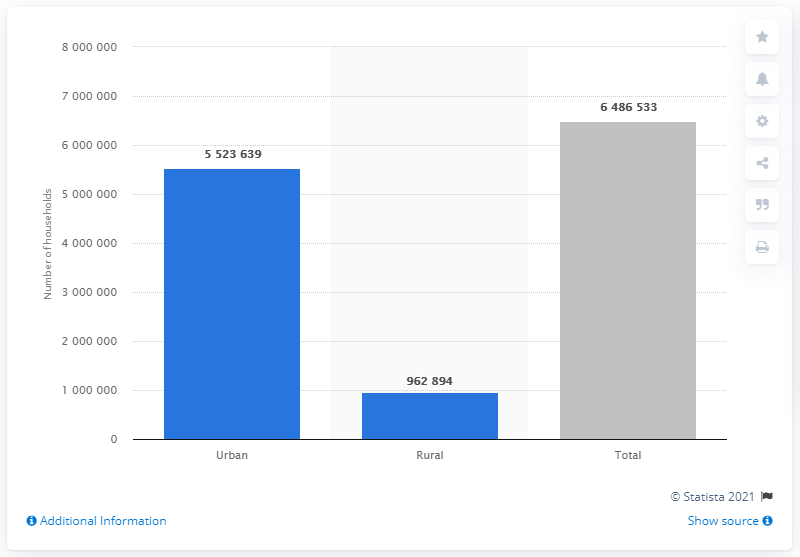What can we infer about the population density in urban areas compared to rural areas in Chile from this chart? From the chart, we can infer that population density is likely to be significantly higher in Chile's urban areas. Given that urban households far outnumber rural ones, this suggests more people live in closer proximity in cities, contributing to denser living conditions. 